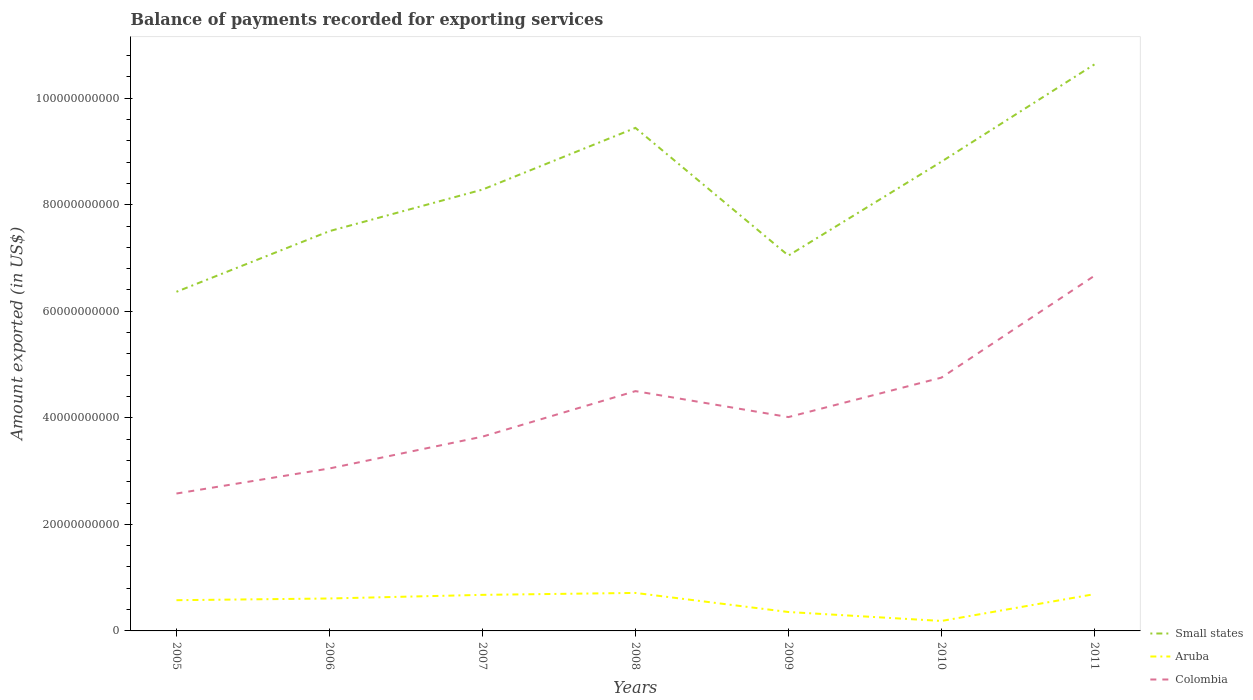Is the number of lines equal to the number of legend labels?
Give a very brief answer. Yes. Across all years, what is the maximum amount exported in Small states?
Ensure brevity in your answer.  6.37e+1. What is the total amount exported in Colombia in the graph?
Make the answer very short. 4.87e+09. What is the difference between the highest and the second highest amount exported in Small states?
Ensure brevity in your answer.  4.27e+1. How many lines are there?
Offer a very short reply. 3. How many years are there in the graph?
Offer a very short reply. 7. What is the difference between two consecutive major ticks on the Y-axis?
Give a very brief answer. 2.00e+1. Are the values on the major ticks of Y-axis written in scientific E-notation?
Provide a succinct answer. No. Does the graph contain any zero values?
Your answer should be compact. No. How many legend labels are there?
Your response must be concise. 3. What is the title of the graph?
Provide a succinct answer. Balance of payments recorded for exporting services. Does "Zambia" appear as one of the legend labels in the graph?
Keep it short and to the point. No. What is the label or title of the X-axis?
Make the answer very short. Years. What is the label or title of the Y-axis?
Your answer should be very brief. Amount exported (in US$). What is the Amount exported (in US$) of Small states in 2005?
Offer a very short reply. 6.37e+1. What is the Amount exported (in US$) in Aruba in 2005?
Provide a short and direct response. 5.77e+09. What is the Amount exported (in US$) in Colombia in 2005?
Provide a succinct answer. 2.58e+1. What is the Amount exported (in US$) in Small states in 2006?
Offer a very short reply. 7.50e+1. What is the Amount exported (in US$) of Aruba in 2006?
Make the answer very short. 6.09e+09. What is the Amount exported (in US$) of Colombia in 2006?
Make the answer very short. 3.05e+1. What is the Amount exported (in US$) in Small states in 2007?
Give a very brief answer. 8.28e+1. What is the Amount exported (in US$) in Aruba in 2007?
Your answer should be very brief. 6.77e+09. What is the Amount exported (in US$) in Colombia in 2007?
Provide a succinct answer. 3.65e+1. What is the Amount exported (in US$) in Small states in 2008?
Make the answer very short. 9.44e+1. What is the Amount exported (in US$) of Aruba in 2008?
Provide a short and direct response. 7.13e+09. What is the Amount exported (in US$) in Colombia in 2008?
Keep it short and to the point. 4.50e+1. What is the Amount exported (in US$) of Small states in 2009?
Provide a succinct answer. 7.05e+1. What is the Amount exported (in US$) of Aruba in 2009?
Offer a very short reply. 3.55e+09. What is the Amount exported (in US$) in Colombia in 2009?
Provide a short and direct response. 4.01e+1. What is the Amount exported (in US$) in Small states in 2010?
Provide a short and direct response. 8.81e+1. What is the Amount exported (in US$) in Aruba in 2010?
Offer a terse response. 1.87e+09. What is the Amount exported (in US$) of Colombia in 2010?
Keep it short and to the point. 4.75e+1. What is the Amount exported (in US$) in Small states in 2011?
Offer a terse response. 1.06e+11. What is the Amount exported (in US$) of Aruba in 2011?
Offer a very short reply. 6.90e+09. What is the Amount exported (in US$) in Colombia in 2011?
Ensure brevity in your answer.  6.67e+1. Across all years, what is the maximum Amount exported (in US$) of Small states?
Provide a short and direct response. 1.06e+11. Across all years, what is the maximum Amount exported (in US$) of Aruba?
Offer a terse response. 7.13e+09. Across all years, what is the maximum Amount exported (in US$) in Colombia?
Keep it short and to the point. 6.67e+1. Across all years, what is the minimum Amount exported (in US$) of Small states?
Ensure brevity in your answer.  6.37e+1. Across all years, what is the minimum Amount exported (in US$) of Aruba?
Keep it short and to the point. 1.87e+09. Across all years, what is the minimum Amount exported (in US$) in Colombia?
Your answer should be very brief. 2.58e+1. What is the total Amount exported (in US$) of Small states in the graph?
Your answer should be very brief. 5.81e+11. What is the total Amount exported (in US$) of Aruba in the graph?
Ensure brevity in your answer.  3.81e+1. What is the total Amount exported (in US$) of Colombia in the graph?
Provide a short and direct response. 2.92e+11. What is the difference between the Amount exported (in US$) in Small states in 2005 and that in 2006?
Provide a short and direct response. -1.14e+1. What is the difference between the Amount exported (in US$) in Aruba in 2005 and that in 2006?
Keep it short and to the point. -3.22e+08. What is the difference between the Amount exported (in US$) of Colombia in 2005 and that in 2006?
Keep it short and to the point. -4.70e+09. What is the difference between the Amount exported (in US$) in Small states in 2005 and that in 2007?
Your response must be concise. -1.92e+1. What is the difference between the Amount exported (in US$) of Aruba in 2005 and that in 2007?
Give a very brief answer. -1.00e+09. What is the difference between the Amount exported (in US$) in Colombia in 2005 and that in 2007?
Ensure brevity in your answer.  -1.07e+1. What is the difference between the Amount exported (in US$) in Small states in 2005 and that in 2008?
Offer a very short reply. -3.08e+1. What is the difference between the Amount exported (in US$) of Aruba in 2005 and that in 2008?
Provide a succinct answer. -1.37e+09. What is the difference between the Amount exported (in US$) in Colombia in 2005 and that in 2008?
Provide a short and direct response. -1.92e+1. What is the difference between the Amount exported (in US$) in Small states in 2005 and that in 2009?
Your answer should be very brief. -6.80e+09. What is the difference between the Amount exported (in US$) of Aruba in 2005 and that in 2009?
Keep it short and to the point. 2.22e+09. What is the difference between the Amount exported (in US$) in Colombia in 2005 and that in 2009?
Make the answer very short. -1.43e+1. What is the difference between the Amount exported (in US$) in Small states in 2005 and that in 2010?
Keep it short and to the point. -2.44e+1. What is the difference between the Amount exported (in US$) of Aruba in 2005 and that in 2010?
Make the answer very short. 3.90e+09. What is the difference between the Amount exported (in US$) of Colombia in 2005 and that in 2010?
Your response must be concise. -2.18e+1. What is the difference between the Amount exported (in US$) of Small states in 2005 and that in 2011?
Your response must be concise. -4.27e+1. What is the difference between the Amount exported (in US$) in Aruba in 2005 and that in 2011?
Provide a succinct answer. -1.14e+09. What is the difference between the Amount exported (in US$) of Colombia in 2005 and that in 2011?
Keep it short and to the point. -4.09e+1. What is the difference between the Amount exported (in US$) in Small states in 2006 and that in 2007?
Your answer should be compact. -7.79e+09. What is the difference between the Amount exported (in US$) of Aruba in 2006 and that in 2007?
Offer a very short reply. -6.80e+08. What is the difference between the Amount exported (in US$) of Colombia in 2006 and that in 2007?
Provide a succinct answer. -5.97e+09. What is the difference between the Amount exported (in US$) of Small states in 2006 and that in 2008?
Make the answer very short. -1.94e+1. What is the difference between the Amount exported (in US$) in Aruba in 2006 and that in 2008?
Your answer should be very brief. -1.04e+09. What is the difference between the Amount exported (in US$) of Colombia in 2006 and that in 2008?
Give a very brief answer. -1.45e+1. What is the difference between the Amount exported (in US$) in Small states in 2006 and that in 2009?
Ensure brevity in your answer.  4.59e+09. What is the difference between the Amount exported (in US$) in Aruba in 2006 and that in 2009?
Offer a terse response. 2.54e+09. What is the difference between the Amount exported (in US$) in Colombia in 2006 and that in 2009?
Ensure brevity in your answer.  -9.64e+09. What is the difference between the Amount exported (in US$) of Small states in 2006 and that in 2010?
Ensure brevity in your answer.  -1.30e+1. What is the difference between the Amount exported (in US$) of Aruba in 2006 and that in 2010?
Provide a short and direct response. 4.22e+09. What is the difference between the Amount exported (in US$) in Colombia in 2006 and that in 2010?
Your response must be concise. -1.71e+1. What is the difference between the Amount exported (in US$) in Small states in 2006 and that in 2011?
Your answer should be very brief. -3.13e+1. What is the difference between the Amount exported (in US$) of Aruba in 2006 and that in 2011?
Your response must be concise. -8.13e+08. What is the difference between the Amount exported (in US$) in Colombia in 2006 and that in 2011?
Keep it short and to the point. -3.62e+1. What is the difference between the Amount exported (in US$) in Small states in 2007 and that in 2008?
Offer a terse response. -1.16e+1. What is the difference between the Amount exported (in US$) of Aruba in 2007 and that in 2008?
Keep it short and to the point. -3.63e+08. What is the difference between the Amount exported (in US$) of Colombia in 2007 and that in 2008?
Your answer should be very brief. -8.55e+09. What is the difference between the Amount exported (in US$) in Small states in 2007 and that in 2009?
Your answer should be very brief. 1.24e+1. What is the difference between the Amount exported (in US$) of Aruba in 2007 and that in 2009?
Your answer should be compact. 3.22e+09. What is the difference between the Amount exported (in US$) of Colombia in 2007 and that in 2009?
Your answer should be compact. -3.67e+09. What is the difference between the Amount exported (in US$) of Small states in 2007 and that in 2010?
Your answer should be compact. -5.24e+09. What is the difference between the Amount exported (in US$) in Aruba in 2007 and that in 2010?
Offer a very short reply. 4.90e+09. What is the difference between the Amount exported (in US$) of Colombia in 2007 and that in 2010?
Provide a succinct answer. -1.11e+1. What is the difference between the Amount exported (in US$) of Small states in 2007 and that in 2011?
Make the answer very short. -2.35e+1. What is the difference between the Amount exported (in US$) of Aruba in 2007 and that in 2011?
Keep it short and to the point. -1.33e+08. What is the difference between the Amount exported (in US$) in Colombia in 2007 and that in 2011?
Provide a short and direct response. -3.02e+1. What is the difference between the Amount exported (in US$) in Small states in 2008 and that in 2009?
Provide a short and direct response. 2.40e+1. What is the difference between the Amount exported (in US$) of Aruba in 2008 and that in 2009?
Give a very brief answer. 3.58e+09. What is the difference between the Amount exported (in US$) in Colombia in 2008 and that in 2009?
Ensure brevity in your answer.  4.87e+09. What is the difference between the Amount exported (in US$) of Small states in 2008 and that in 2010?
Make the answer very short. 6.34e+09. What is the difference between the Amount exported (in US$) of Aruba in 2008 and that in 2010?
Provide a short and direct response. 5.26e+09. What is the difference between the Amount exported (in US$) of Colombia in 2008 and that in 2010?
Keep it short and to the point. -2.53e+09. What is the difference between the Amount exported (in US$) of Small states in 2008 and that in 2011?
Make the answer very short. -1.19e+1. What is the difference between the Amount exported (in US$) in Aruba in 2008 and that in 2011?
Your answer should be compact. 2.30e+08. What is the difference between the Amount exported (in US$) of Colombia in 2008 and that in 2011?
Keep it short and to the point. -2.17e+1. What is the difference between the Amount exported (in US$) in Small states in 2009 and that in 2010?
Provide a short and direct response. -1.76e+1. What is the difference between the Amount exported (in US$) in Aruba in 2009 and that in 2010?
Make the answer very short. 1.68e+09. What is the difference between the Amount exported (in US$) of Colombia in 2009 and that in 2010?
Provide a short and direct response. -7.41e+09. What is the difference between the Amount exported (in US$) of Small states in 2009 and that in 2011?
Keep it short and to the point. -3.59e+1. What is the difference between the Amount exported (in US$) in Aruba in 2009 and that in 2011?
Make the answer very short. -3.35e+09. What is the difference between the Amount exported (in US$) in Colombia in 2009 and that in 2011?
Your response must be concise. -2.65e+1. What is the difference between the Amount exported (in US$) in Small states in 2010 and that in 2011?
Give a very brief answer. -1.83e+1. What is the difference between the Amount exported (in US$) of Aruba in 2010 and that in 2011?
Keep it short and to the point. -5.03e+09. What is the difference between the Amount exported (in US$) in Colombia in 2010 and that in 2011?
Give a very brief answer. -1.91e+1. What is the difference between the Amount exported (in US$) of Small states in 2005 and the Amount exported (in US$) of Aruba in 2006?
Your answer should be compact. 5.76e+1. What is the difference between the Amount exported (in US$) in Small states in 2005 and the Amount exported (in US$) in Colombia in 2006?
Keep it short and to the point. 3.32e+1. What is the difference between the Amount exported (in US$) in Aruba in 2005 and the Amount exported (in US$) in Colombia in 2006?
Make the answer very short. -2.47e+1. What is the difference between the Amount exported (in US$) in Small states in 2005 and the Amount exported (in US$) in Aruba in 2007?
Your answer should be compact. 5.69e+1. What is the difference between the Amount exported (in US$) of Small states in 2005 and the Amount exported (in US$) of Colombia in 2007?
Offer a terse response. 2.72e+1. What is the difference between the Amount exported (in US$) in Aruba in 2005 and the Amount exported (in US$) in Colombia in 2007?
Ensure brevity in your answer.  -3.07e+1. What is the difference between the Amount exported (in US$) of Small states in 2005 and the Amount exported (in US$) of Aruba in 2008?
Your response must be concise. 5.65e+1. What is the difference between the Amount exported (in US$) of Small states in 2005 and the Amount exported (in US$) of Colombia in 2008?
Offer a terse response. 1.86e+1. What is the difference between the Amount exported (in US$) of Aruba in 2005 and the Amount exported (in US$) of Colombia in 2008?
Ensure brevity in your answer.  -3.92e+1. What is the difference between the Amount exported (in US$) of Small states in 2005 and the Amount exported (in US$) of Aruba in 2009?
Provide a succinct answer. 6.01e+1. What is the difference between the Amount exported (in US$) in Small states in 2005 and the Amount exported (in US$) in Colombia in 2009?
Offer a very short reply. 2.35e+1. What is the difference between the Amount exported (in US$) of Aruba in 2005 and the Amount exported (in US$) of Colombia in 2009?
Make the answer very short. -3.44e+1. What is the difference between the Amount exported (in US$) in Small states in 2005 and the Amount exported (in US$) in Aruba in 2010?
Your answer should be compact. 6.18e+1. What is the difference between the Amount exported (in US$) of Small states in 2005 and the Amount exported (in US$) of Colombia in 2010?
Your answer should be very brief. 1.61e+1. What is the difference between the Amount exported (in US$) of Aruba in 2005 and the Amount exported (in US$) of Colombia in 2010?
Provide a short and direct response. -4.18e+1. What is the difference between the Amount exported (in US$) in Small states in 2005 and the Amount exported (in US$) in Aruba in 2011?
Your response must be concise. 5.68e+1. What is the difference between the Amount exported (in US$) in Small states in 2005 and the Amount exported (in US$) in Colombia in 2011?
Ensure brevity in your answer.  -3.01e+09. What is the difference between the Amount exported (in US$) in Aruba in 2005 and the Amount exported (in US$) in Colombia in 2011?
Provide a short and direct response. -6.09e+1. What is the difference between the Amount exported (in US$) of Small states in 2006 and the Amount exported (in US$) of Aruba in 2007?
Give a very brief answer. 6.83e+1. What is the difference between the Amount exported (in US$) in Small states in 2006 and the Amount exported (in US$) in Colombia in 2007?
Offer a terse response. 3.86e+1. What is the difference between the Amount exported (in US$) of Aruba in 2006 and the Amount exported (in US$) of Colombia in 2007?
Your response must be concise. -3.04e+1. What is the difference between the Amount exported (in US$) of Small states in 2006 and the Amount exported (in US$) of Aruba in 2008?
Make the answer very short. 6.79e+1. What is the difference between the Amount exported (in US$) of Small states in 2006 and the Amount exported (in US$) of Colombia in 2008?
Provide a short and direct response. 3.00e+1. What is the difference between the Amount exported (in US$) of Aruba in 2006 and the Amount exported (in US$) of Colombia in 2008?
Provide a short and direct response. -3.89e+1. What is the difference between the Amount exported (in US$) in Small states in 2006 and the Amount exported (in US$) in Aruba in 2009?
Keep it short and to the point. 7.15e+1. What is the difference between the Amount exported (in US$) in Small states in 2006 and the Amount exported (in US$) in Colombia in 2009?
Your response must be concise. 3.49e+1. What is the difference between the Amount exported (in US$) of Aruba in 2006 and the Amount exported (in US$) of Colombia in 2009?
Give a very brief answer. -3.40e+1. What is the difference between the Amount exported (in US$) in Small states in 2006 and the Amount exported (in US$) in Aruba in 2010?
Ensure brevity in your answer.  7.32e+1. What is the difference between the Amount exported (in US$) of Small states in 2006 and the Amount exported (in US$) of Colombia in 2010?
Keep it short and to the point. 2.75e+1. What is the difference between the Amount exported (in US$) of Aruba in 2006 and the Amount exported (in US$) of Colombia in 2010?
Provide a short and direct response. -4.15e+1. What is the difference between the Amount exported (in US$) of Small states in 2006 and the Amount exported (in US$) of Aruba in 2011?
Your answer should be compact. 6.81e+1. What is the difference between the Amount exported (in US$) of Small states in 2006 and the Amount exported (in US$) of Colombia in 2011?
Provide a short and direct response. 8.38e+09. What is the difference between the Amount exported (in US$) in Aruba in 2006 and the Amount exported (in US$) in Colombia in 2011?
Provide a succinct answer. -6.06e+1. What is the difference between the Amount exported (in US$) in Small states in 2007 and the Amount exported (in US$) in Aruba in 2008?
Your answer should be very brief. 7.57e+1. What is the difference between the Amount exported (in US$) in Small states in 2007 and the Amount exported (in US$) in Colombia in 2008?
Make the answer very short. 3.78e+1. What is the difference between the Amount exported (in US$) in Aruba in 2007 and the Amount exported (in US$) in Colombia in 2008?
Your response must be concise. -3.82e+1. What is the difference between the Amount exported (in US$) of Small states in 2007 and the Amount exported (in US$) of Aruba in 2009?
Give a very brief answer. 7.93e+1. What is the difference between the Amount exported (in US$) in Small states in 2007 and the Amount exported (in US$) in Colombia in 2009?
Provide a short and direct response. 4.27e+1. What is the difference between the Amount exported (in US$) in Aruba in 2007 and the Amount exported (in US$) in Colombia in 2009?
Your response must be concise. -3.34e+1. What is the difference between the Amount exported (in US$) of Small states in 2007 and the Amount exported (in US$) of Aruba in 2010?
Give a very brief answer. 8.10e+1. What is the difference between the Amount exported (in US$) in Small states in 2007 and the Amount exported (in US$) in Colombia in 2010?
Give a very brief answer. 3.53e+1. What is the difference between the Amount exported (in US$) of Aruba in 2007 and the Amount exported (in US$) of Colombia in 2010?
Provide a succinct answer. -4.08e+1. What is the difference between the Amount exported (in US$) of Small states in 2007 and the Amount exported (in US$) of Aruba in 2011?
Your answer should be very brief. 7.59e+1. What is the difference between the Amount exported (in US$) of Small states in 2007 and the Amount exported (in US$) of Colombia in 2011?
Make the answer very short. 1.62e+1. What is the difference between the Amount exported (in US$) of Aruba in 2007 and the Amount exported (in US$) of Colombia in 2011?
Provide a succinct answer. -5.99e+1. What is the difference between the Amount exported (in US$) in Small states in 2008 and the Amount exported (in US$) in Aruba in 2009?
Your answer should be compact. 9.09e+1. What is the difference between the Amount exported (in US$) in Small states in 2008 and the Amount exported (in US$) in Colombia in 2009?
Your response must be concise. 5.43e+1. What is the difference between the Amount exported (in US$) of Aruba in 2008 and the Amount exported (in US$) of Colombia in 2009?
Your answer should be very brief. -3.30e+1. What is the difference between the Amount exported (in US$) in Small states in 2008 and the Amount exported (in US$) in Aruba in 2010?
Keep it short and to the point. 9.25e+1. What is the difference between the Amount exported (in US$) in Small states in 2008 and the Amount exported (in US$) in Colombia in 2010?
Provide a succinct answer. 4.69e+1. What is the difference between the Amount exported (in US$) of Aruba in 2008 and the Amount exported (in US$) of Colombia in 2010?
Provide a short and direct response. -4.04e+1. What is the difference between the Amount exported (in US$) of Small states in 2008 and the Amount exported (in US$) of Aruba in 2011?
Provide a succinct answer. 8.75e+1. What is the difference between the Amount exported (in US$) of Small states in 2008 and the Amount exported (in US$) of Colombia in 2011?
Make the answer very short. 2.78e+1. What is the difference between the Amount exported (in US$) in Aruba in 2008 and the Amount exported (in US$) in Colombia in 2011?
Ensure brevity in your answer.  -5.95e+1. What is the difference between the Amount exported (in US$) in Small states in 2009 and the Amount exported (in US$) in Aruba in 2010?
Offer a terse response. 6.86e+1. What is the difference between the Amount exported (in US$) in Small states in 2009 and the Amount exported (in US$) in Colombia in 2010?
Offer a very short reply. 2.29e+1. What is the difference between the Amount exported (in US$) of Aruba in 2009 and the Amount exported (in US$) of Colombia in 2010?
Ensure brevity in your answer.  -4.40e+1. What is the difference between the Amount exported (in US$) in Small states in 2009 and the Amount exported (in US$) in Aruba in 2011?
Your answer should be compact. 6.35e+1. What is the difference between the Amount exported (in US$) of Small states in 2009 and the Amount exported (in US$) of Colombia in 2011?
Your answer should be very brief. 3.79e+09. What is the difference between the Amount exported (in US$) in Aruba in 2009 and the Amount exported (in US$) in Colombia in 2011?
Provide a short and direct response. -6.31e+1. What is the difference between the Amount exported (in US$) of Small states in 2010 and the Amount exported (in US$) of Aruba in 2011?
Your response must be concise. 8.12e+1. What is the difference between the Amount exported (in US$) in Small states in 2010 and the Amount exported (in US$) in Colombia in 2011?
Offer a terse response. 2.14e+1. What is the difference between the Amount exported (in US$) of Aruba in 2010 and the Amount exported (in US$) of Colombia in 2011?
Your answer should be compact. -6.48e+1. What is the average Amount exported (in US$) in Small states per year?
Provide a short and direct response. 8.30e+1. What is the average Amount exported (in US$) in Aruba per year?
Provide a short and direct response. 5.44e+09. What is the average Amount exported (in US$) of Colombia per year?
Your response must be concise. 4.17e+1. In the year 2005, what is the difference between the Amount exported (in US$) of Small states and Amount exported (in US$) of Aruba?
Your response must be concise. 5.79e+1. In the year 2005, what is the difference between the Amount exported (in US$) of Small states and Amount exported (in US$) of Colombia?
Offer a terse response. 3.79e+1. In the year 2005, what is the difference between the Amount exported (in US$) of Aruba and Amount exported (in US$) of Colombia?
Provide a short and direct response. -2.00e+1. In the year 2006, what is the difference between the Amount exported (in US$) in Small states and Amount exported (in US$) in Aruba?
Keep it short and to the point. 6.90e+1. In the year 2006, what is the difference between the Amount exported (in US$) in Small states and Amount exported (in US$) in Colombia?
Your answer should be very brief. 4.45e+1. In the year 2006, what is the difference between the Amount exported (in US$) in Aruba and Amount exported (in US$) in Colombia?
Your response must be concise. -2.44e+1. In the year 2007, what is the difference between the Amount exported (in US$) in Small states and Amount exported (in US$) in Aruba?
Offer a very short reply. 7.61e+1. In the year 2007, what is the difference between the Amount exported (in US$) in Small states and Amount exported (in US$) in Colombia?
Your answer should be very brief. 4.64e+1. In the year 2007, what is the difference between the Amount exported (in US$) in Aruba and Amount exported (in US$) in Colombia?
Provide a succinct answer. -2.97e+1. In the year 2008, what is the difference between the Amount exported (in US$) of Small states and Amount exported (in US$) of Aruba?
Offer a very short reply. 8.73e+1. In the year 2008, what is the difference between the Amount exported (in US$) in Small states and Amount exported (in US$) in Colombia?
Provide a succinct answer. 4.94e+1. In the year 2008, what is the difference between the Amount exported (in US$) of Aruba and Amount exported (in US$) of Colombia?
Keep it short and to the point. -3.79e+1. In the year 2009, what is the difference between the Amount exported (in US$) of Small states and Amount exported (in US$) of Aruba?
Ensure brevity in your answer.  6.69e+1. In the year 2009, what is the difference between the Amount exported (in US$) in Small states and Amount exported (in US$) in Colombia?
Offer a terse response. 3.03e+1. In the year 2009, what is the difference between the Amount exported (in US$) in Aruba and Amount exported (in US$) in Colombia?
Give a very brief answer. -3.66e+1. In the year 2010, what is the difference between the Amount exported (in US$) in Small states and Amount exported (in US$) in Aruba?
Offer a terse response. 8.62e+1. In the year 2010, what is the difference between the Amount exported (in US$) in Small states and Amount exported (in US$) in Colombia?
Provide a succinct answer. 4.05e+1. In the year 2010, what is the difference between the Amount exported (in US$) in Aruba and Amount exported (in US$) in Colombia?
Provide a short and direct response. -4.57e+1. In the year 2011, what is the difference between the Amount exported (in US$) of Small states and Amount exported (in US$) of Aruba?
Keep it short and to the point. 9.94e+1. In the year 2011, what is the difference between the Amount exported (in US$) in Small states and Amount exported (in US$) in Colombia?
Keep it short and to the point. 3.97e+1. In the year 2011, what is the difference between the Amount exported (in US$) in Aruba and Amount exported (in US$) in Colombia?
Offer a very short reply. -5.98e+1. What is the ratio of the Amount exported (in US$) of Small states in 2005 to that in 2006?
Your response must be concise. 0.85. What is the ratio of the Amount exported (in US$) in Aruba in 2005 to that in 2006?
Provide a short and direct response. 0.95. What is the ratio of the Amount exported (in US$) in Colombia in 2005 to that in 2006?
Your response must be concise. 0.85. What is the ratio of the Amount exported (in US$) in Small states in 2005 to that in 2007?
Provide a succinct answer. 0.77. What is the ratio of the Amount exported (in US$) of Aruba in 2005 to that in 2007?
Give a very brief answer. 0.85. What is the ratio of the Amount exported (in US$) in Colombia in 2005 to that in 2007?
Your answer should be very brief. 0.71. What is the ratio of the Amount exported (in US$) in Small states in 2005 to that in 2008?
Your answer should be very brief. 0.67. What is the ratio of the Amount exported (in US$) in Aruba in 2005 to that in 2008?
Provide a succinct answer. 0.81. What is the ratio of the Amount exported (in US$) in Colombia in 2005 to that in 2008?
Provide a short and direct response. 0.57. What is the ratio of the Amount exported (in US$) of Small states in 2005 to that in 2009?
Keep it short and to the point. 0.9. What is the ratio of the Amount exported (in US$) in Aruba in 2005 to that in 2009?
Your answer should be very brief. 1.62. What is the ratio of the Amount exported (in US$) in Colombia in 2005 to that in 2009?
Keep it short and to the point. 0.64. What is the ratio of the Amount exported (in US$) of Small states in 2005 to that in 2010?
Your answer should be compact. 0.72. What is the ratio of the Amount exported (in US$) of Aruba in 2005 to that in 2010?
Make the answer very short. 3.08. What is the ratio of the Amount exported (in US$) of Colombia in 2005 to that in 2010?
Offer a very short reply. 0.54. What is the ratio of the Amount exported (in US$) of Small states in 2005 to that in 2011?
Offer a very short reply. 0.6. What is the ratio of the Amount exported (in US$) of Aruba in 2005 to that in 2011?
Your answer should be compact. 0.84. What is the ratio of the Amount exported (in US$) of Colombia in 2005 to that in 2011?
Give a very brief answer. 0.39. What is the ratio of the Amount exported (in US$) in Small states in 2006 to that in 2007?
Offer a terse response. 0.91. What is the ratio of the Amount exported (in US$) in Aruba in 2006 to that in 2007?
Provide a short and direct response. 0.9. What is the ratio of the Amount exported (in US$) of Colombia in 2006 to that in 2007?
Offer a terse response. 0.84. What is the ratio of the Amount exported (in US$) of Small states in 2006 to that in 2008?
Your answer should be very brief. 0.79. What is the ratio of the Amount exported (in US$) in Aruba in 2006 to that in 2008?
Your answer should be compact. 0.85. What is the ratio of the Amount exported (in US$) in Colombia in 2006 to that in 2008?
Ensure brevity in your answer.  0.68. What is the ratio of the Amount exported (in US$) of Small states in 2006 to that in 2009?
Your response must be concise. 1.07. What is the ratio of the Amount exported (in US$) of Aruba in 2006 to that in 2009?
Offer a terse response. 1.72. What is the ratio of the Amount exported (in US$) of Colombia in 2006 to that in 2009?
Your answer should be compact. 0.76. What is the ratio of the Amount exported (in US$) in Small states in 2006 to that in 2010?
Make the answer very short. 0.85. What is the ratio of the Amount exported (in US$) of Aruba in 2006 to that in 2010?
Make the answer very short. 3.25. What is the ratio of the Amount exported (in US$) of Colombia in 2006 to that in 2010?
Your answer should be very brief. 0.64. What is the ratio of the Amount exported (in US$) in Small states in 2006 to that in 2011?
Keep it short and to the point. 0.71. What is the ratio of the Amount exported (in US$) of Aruba in 2006 to that in 2011?
Keep it short and to the point. 0.88. What is the ratio of the Amount exported (in US$) in Colombia in 2006 to that in 2011?
Offer a very short reply. 0.46. What is the ratio of the Amount exported (in US$) of Small states in 2007 to that in 2008?
Give a very brief answer. 0.88. What is the ratio of the Amount exported (in US$) in Aruba in 2007 to that in 2008?
Your answer should be very brief. 0.95. What is the ratio of the Amount exported (in US$) in Colombia in 2007 to that in 2008?
Offer a terse response. 0.81. What is the ratio of the Amount exported (in US$) in Small states in 2007 to that in 2009?
Offer a very short reply. 1.18. What is the ratio of the Amount exported (in US$) in Aruba in 2007 to that in 2009?
Make the answer very short. 1.91. What is the ratio of the Amount exported (in US$) in Colombia in 2007 to that in 2009?
Keep it short and to the point. 0.91. What is the ratio of the Amount exported (in US$) in Small states in 2007 to that in 2010?
Keep it short and to the point. 0.94. What is the ratio of the Amount exported (in US$) of Aruba in 2007 to that in 2010?
Your answer should be very brief. 3.62. What is the ratio of the Amount exported (in US$) of Colombia in 2007 to that in 2010?
Offer a terse response. 0.77. What is the ratio of the Amount exported (in US$) in Small states in 2007 to that in 2011?
Provide a succinct answer. 0.78. What is the ratio of the Amount exported (in US$) in Aruba in 2007 to that in 2011?
Offer a terse response. 0.98. What is the ratio of the Amount exported (in US$) of Colombia in 2007 to that in 2011?
Provide a short and direct response. 0.55. What is the ratio of the Amount exported (in US$) in Small states in 2008 to that in 2009?
Provide a short and direct response. 1.34. What is the ratio of the Amount exported (in US$) of Aruba in 2008 to that in 2009?
Offer a very short reply. 2.01. What is the ratio of the Amount exported (in US$) of Colombia in 2008 to that in 2009?
Give a very brief answer. 1.12. What is the ratio of the Amount exported (in US$) of Small states in 2008 to that in 2010?
Provide a short and direct response. 1.07. What is the ratio of the Amount exported (in US$) of Aruba in 2008 to that in 2010?
Offer a terse response. 3.81. What is the ratio of the Amount exported (in US$) in Colombia in 2008 to that in 2010?
Offer a terse response. 0.95. What is the ratio of the Amount exported (in US$) of Small states in 2008 to that in 2011?
Make the answer very short. 0.89. What is the ratio of the Amount exported (in US$) of Colombia in 2008 to that in 2011?
Make the answer very short. 0.68. What is the ratio of the Amount exported (in US$) in Small states in 2009 to that in 2010?
Offer a terse response. 0.8. What is the ratio of the Amount exported (in US$) of Aruba in 2009 to that in 2010?
Your answer should be very brief. 1.9. What is the ratio of the Amount exported (in US$) of Colombia in 2009 to that in 2010?
Make the answer very short. 0.84. What is the ratio of the Amount exported (in US$) in Small states in 2009 to that in 2011?
Provide a succinct answer. 0.66. What is the ratio of the Amount exported (in US$) in Aruba in 2009 to that in 2011?
Keep it short and to the point. 0.51. What is the ratio of the Amount exported (in US$) of Colombia in 2009 to that in 2011?
Offer a very short reply. 0.6. What is the ratio of the Amount exported (in US$) of Small states in 2010 to that in 2011?
Ensure brevity in your answer.  0.83. What is the ratio of the Amount exported (in US$) in Aruba in 2010 to that in 2011?
Your response must be concise. 0.27. What is the ratio of the Amount exported (in US$) in Colombia in 2010 to that in 2011?
Offer a terse response. 0.71. What is the difference between the highest and the second highest Amount exported (in US$) in Small states?
Make the answer very short. 1.19e+1. What is the difference between the highest and the second highest Amount exported (in US$) in Aruba?
Give a very brief answer. 2.30e+08. What is the difference between the highest and the second highest Amount exported (in US$) in Colombia?
Your answer should be very brief. 1.91e+1. What is the difference between the highest and the lowest Amount exported (in US$) of Small states?
Keep it short and to the point. 4.27e+1. What is the difference between the highest and the lowest Amount exported (in US$) in Aruba?
Make the answer very short. 5.26e+09. What is the difference between the highest and the lowest Amount exported (in US$) in Colombia?
Give a very brief answer. 4.09e+1. 